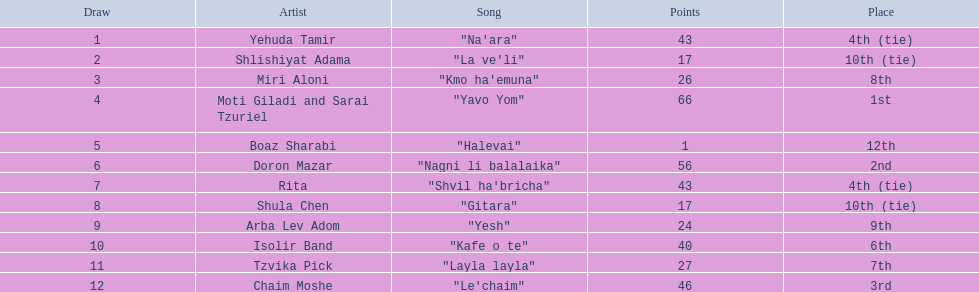What is the total number of artists? Yehuda Tamir, Shlishiyat Adama, Miri Aloni, Moti Giladi and Sarai Tzuriel, Boaz Sharabi, Doron Mazar, Rita, Shula Chen, Arba Lev Adom, Isolir Band, Tzvika Pick, Chaim Moshe. What is the minimum number of points given? 1. Which artist received that minimum points? Boaz Sharabi. 